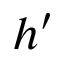<formula> <loc_0><loc_0><loc_500><loc_500>h ^ { \prime }</formula> 